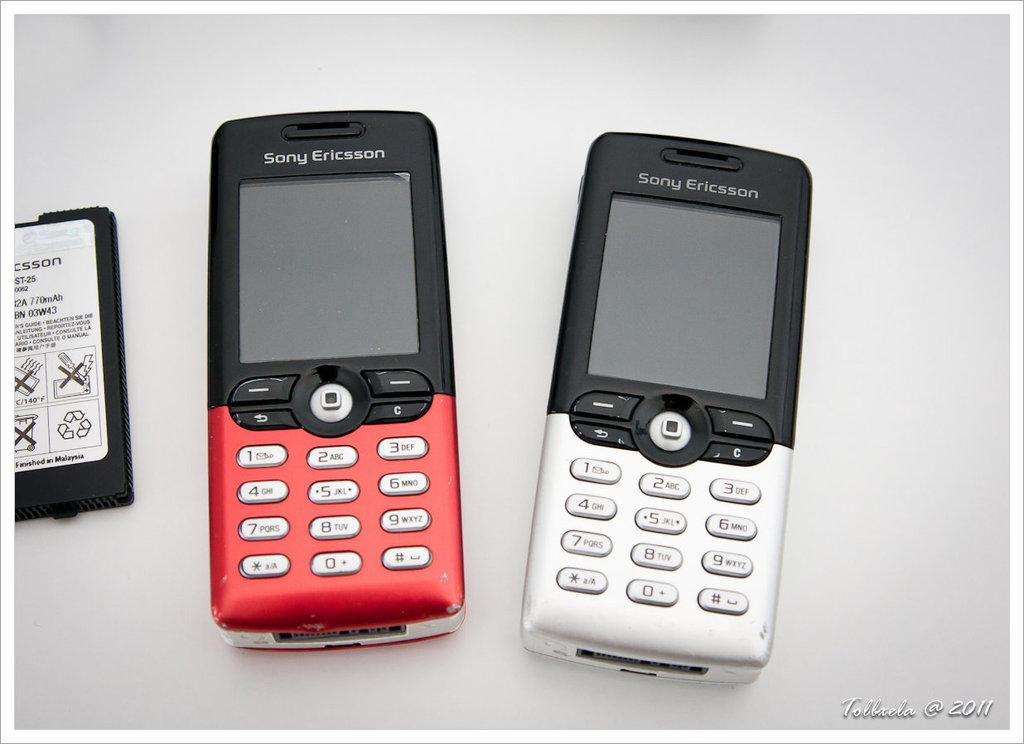Provide a one-sentence caption for the provided image. A battery sits next to 2 Sony Ericcson phones, one red and one white. 